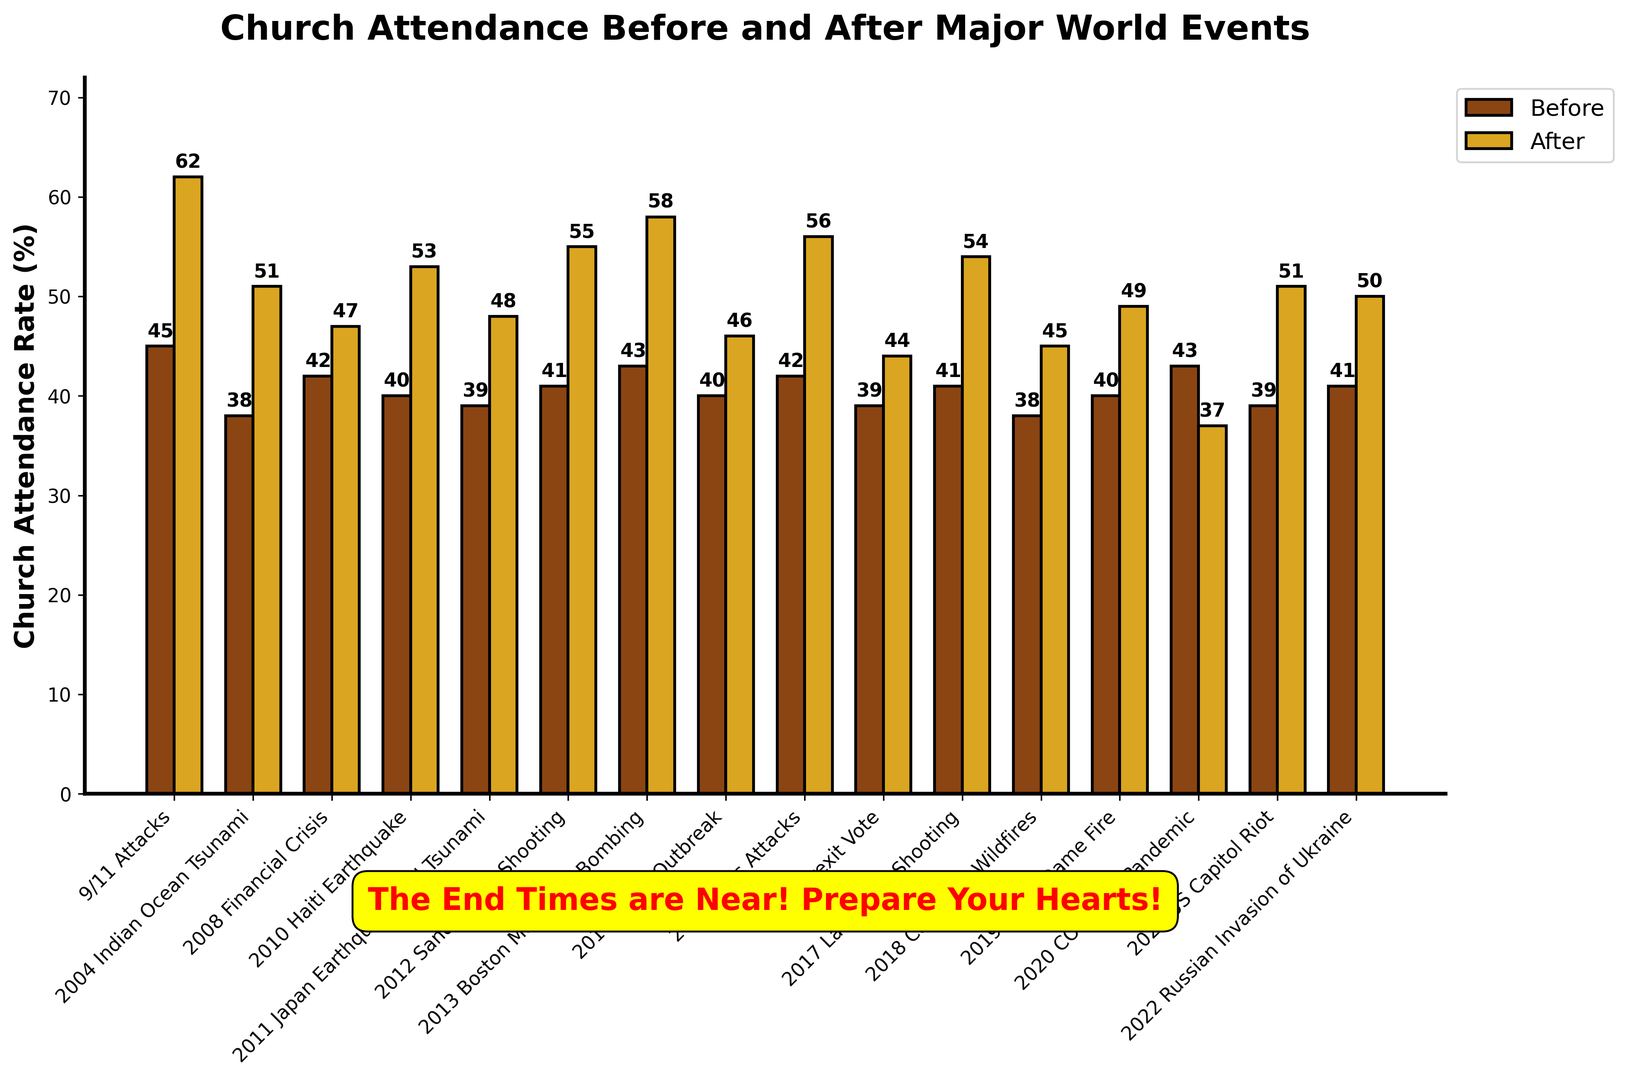Which event showed the largest increase in church attendance rates? To determine which event showed the largest increase, calculate the difference between the "After" and "Before" values for each event, and identify the event with the highest value. The differences are: 9/11 Attacks (17), 2004 Indian Ocean Tsunami (13), 2008 Financial Crisis (5), 2010 Haiti Earthquake (13), 2011 Japan Earthquake and Tsunami (9), 2012 Sandy Hook Shooting (14), 2013 Boston Marathon Bombing (15), 2014 Ebola Outbreak (6), 2015 Paris Attacks (14), 2016 Brexit Vote (5), 2017 Las Vegas Shooting (13), 2018 California Wildfires (7), 2019 Notre Dame Fire (9), 2020 COVID-19 Pandemic (-6), 2021 US Capitol Riot (12), 2022 Russian Invasion of Ukraine (9). The 9/11 Attacks showed the largest increase (17).
Answer: 9/11 Attacks Which event had a decrease in church attendance rates after it occurred? Look for the event where the "After" value is less than the "Before" value. The 2020 COVID-19 Pandemic has an "After" value (37) that is less than the "Before" value (43), indicating a decrease.
Answer: 2020 COVID-19 Pandemic How many events had an increase of more than 10 percentage points in church attendance? Identify events with a difference between "After" and "Before" greater than 10. The events are: 9/11 Attacks (17), 2004 Indian Ocean Tsunami (13), 2010 Haiti Earthquake (13), 2012 Sandy Hook Shooting (14), 2013 Boston Marathon Bombing (15), 2015 Paris Attacks (14), 2017 Las Vegas Shooting (13). There are 7 such events.
Answer: 7 Which two events had the closest "After" church attendance rates? Compare the "After" values and find the two that are closest in number. The closest values are for the 2015 Paris Attacks (56) and 2012 Sandy Hook Shooting (55), which have a difference of 1 percentage point.
Answer: 2015 Paris Attacks and 2012 Sandy Hook Shooting What is the average "Before" church attendance rate for all the events? Calculate the average of the "Before" values: (45 + 38 + 42 + 40 + 39 + 41 + 43 + 40 + 42 + 39 + 41 + 38 + 40 + 43 + 39 + 41)/16 = 41.0625.
Answer: 41.0625 Compare the "Before" and "After" rates for the 2021 US Capitol Riot. Was there an increase and by how much? The "Before" rate for the 2021 US Capitol Riot is 39, and the "After" rate is 51. To determine the increase, subtract the "Before" rate from the "After" rate: 51 - 39 = 12.
Answer: There was an increase of 12 percentage points Which event had the smallest change in church attendance, and what was it? Calculate the absolute differences between "Before" and "After" for each event, and find the smallest difference. The smallest difference is for the 2008 Financial Crisis (5).
Answer: 2008 Financial Crisis (5) What was the total "After" church attendance rate for events in 2020 and beyond? Sum up the "After" values for events from 2020 onwards: COVID-19 Pandemic (37) + US Capitol Riot (51) + Russian Invasion of Ukraine (50) = 138.
Answer: 138 